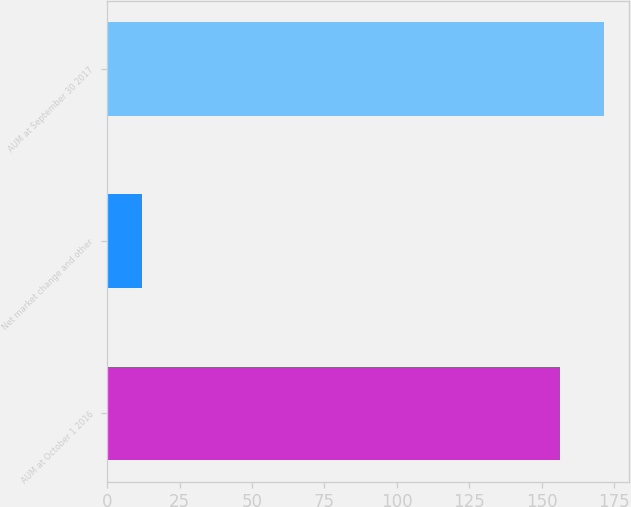Convert chart. <chart><loc_0><loc_0><loc_500><loc_500><bar_chart><fcel>AUM at October 1 2016<fcel>Net market change and other<fcel>AUM at September 30 2017<nl><fcel>156.2<fcel>11.9<fcel>171.51<nl></chart> 